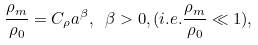<formula> <loc_0><loc_0><loc_500><loc_500>\frac { \rho _ { m } } { \rho _ { 0 } } = C _ { \rho } a ^ { \beta } , \ \beta > 0 , ( i . e . \frac { \rho _ { m } } { \rho _ { 0 } } \ll 1 ) ,</formula> 